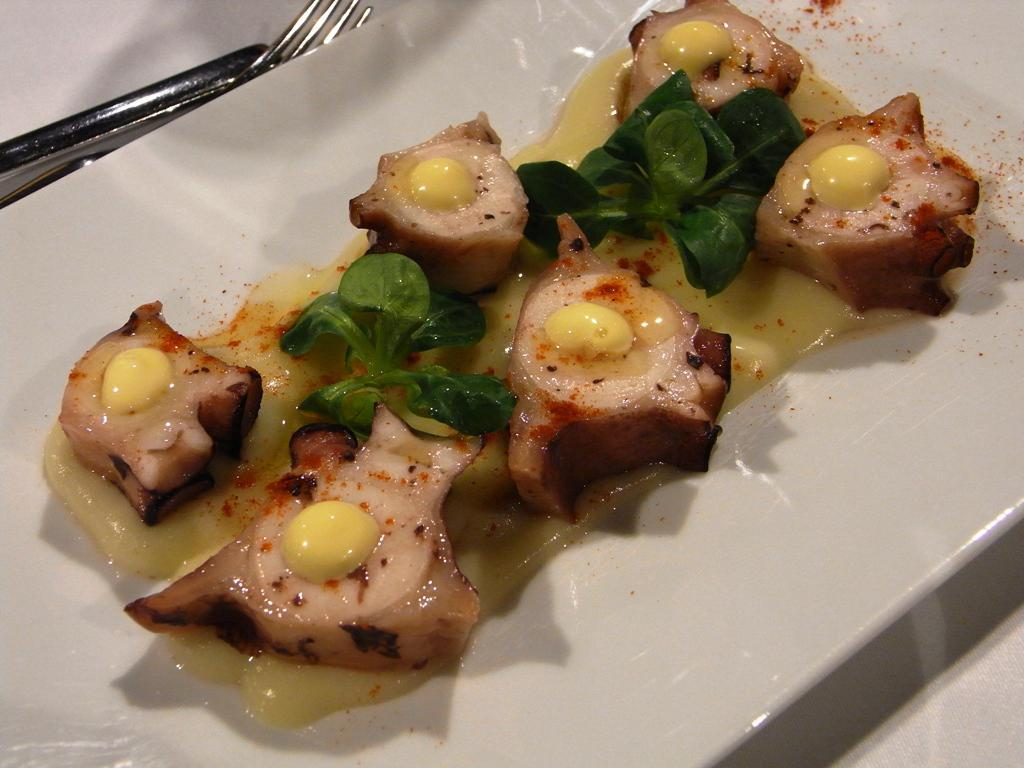What is the main object in the center of the image? There is a table in the center of the image. What utensil can be seen on the table? There is a fork on the table. What is used to serve food on the table? There is a plate on the table. What else is present on the table besides the fork and plate? There are other objects on the table. What type of food is on the plate? There is a food item on the plate. How many women are present in the image? There is no information about women in the image, as it only features a table with various objects. What type of office furniture is visible in the image? There is no office furniture present in the image; it only features a table with various objects. 